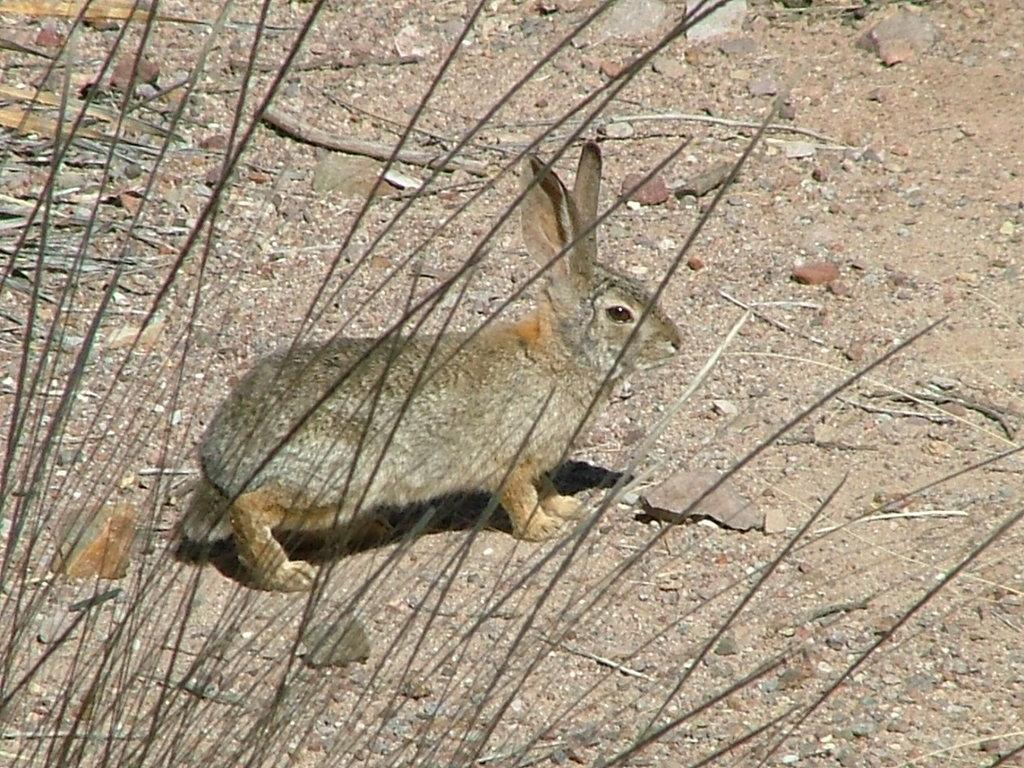What animal is present in the image? There is a rabbit in the image. Where is the rabbit located? The rabbit is on the ground. What type of vegetation is near the rabbit? There are dry plants beside the rabbit. What type of umbrella is the rabbit holding in the image? There is no umbrella present in the image; the rabbit is not holding anything. 